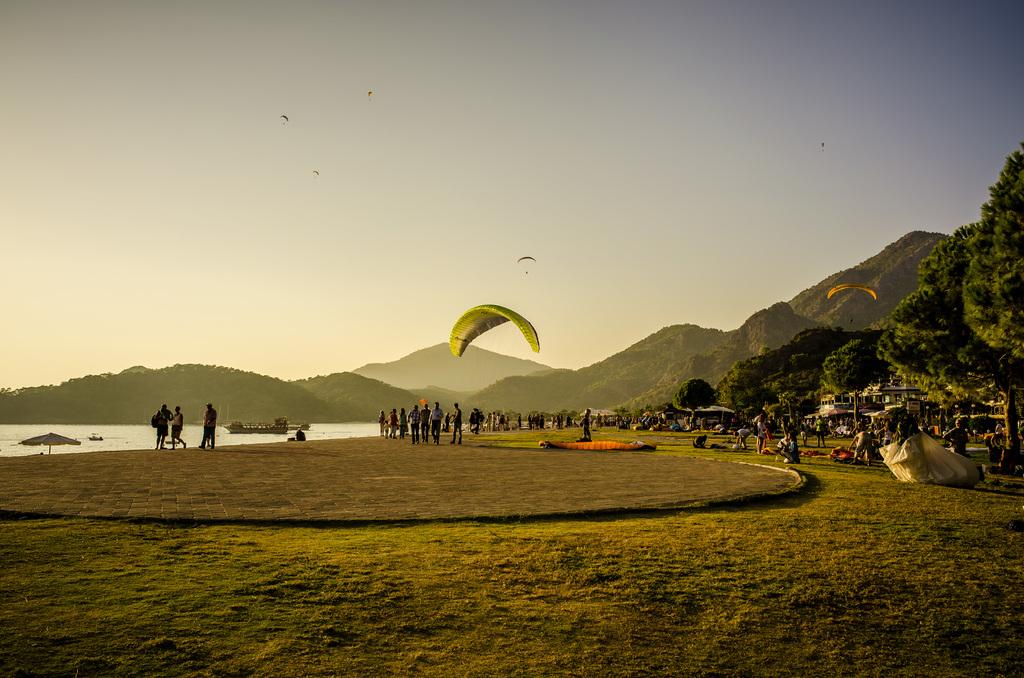What activity is taking place in the air in the image? There is paragliding in the air in the image. What type of terrain is visible in the image? There is grass visible in the image. Can you describe the people in the image? There are people in the image, but their specific actions or roles are not clear from the provided facts. What structures can be seen in the background of the image? There are houses in the background of the image. What other objects or features can be seen in the background of the image? Boats are present above the water, trees are visible, there are hills, and the sky is visible in the background of the image. How many snakes are slithering on the edge of the hill in the image? There are no snakes present in the image, and therefore no such activity can be observed. 